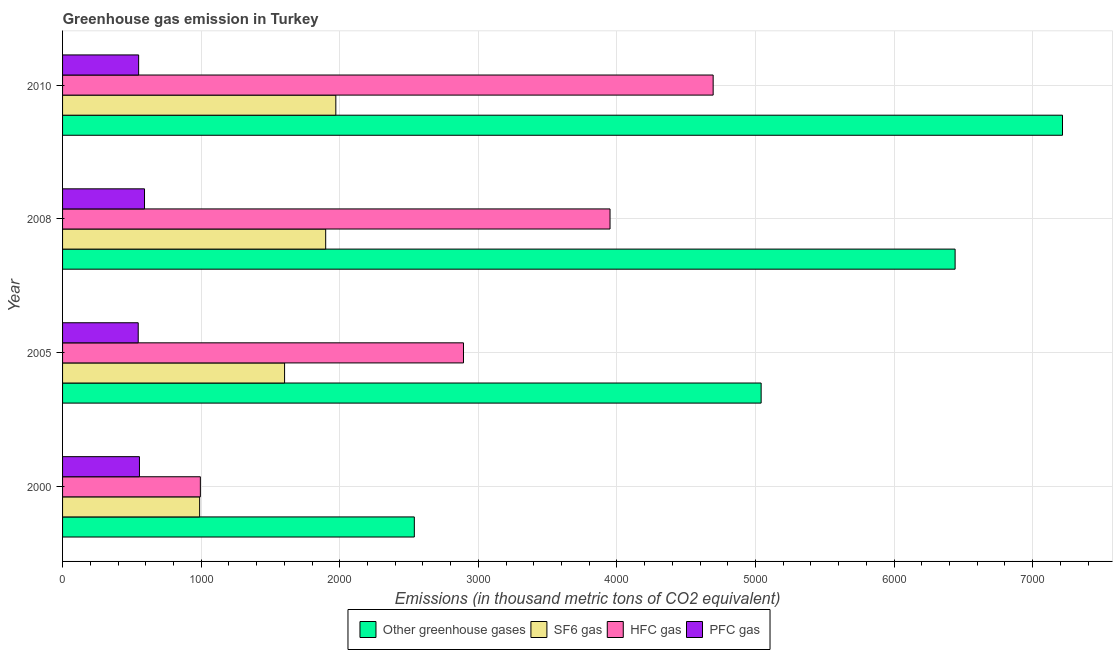How many different coloured bars are there?
Give a very brief answer. 4. How many groups of bars are there?
Give a very brief answer. 4. Are the number of bars per tick equal to the number of legend labels?
Provide a short and direct response. Yes. Are the number of bars on each tick of the Y-axis equal?
Make the answer very short. Yes. How many bars are there on the 3rd tick from the top?
Make the answer very short. 4. What is the label of the 1st group of bars from the top?
Provide a succinct answer. 2010. What is the emission of pfc gas in 2005?
Provide a short and direct response. 545.9. Across all years, what is the maximum emission of sf6 gas?
Offer a very short reply. 1972. Across all years, what is the minimum emission of hfc gas?
Provide a short and direct response. 994.4. What is the total emission of sf6 gas in the graph?
Your response must be concise. 6462.2. What is the difference between the emission of hfc gas in 2005 and that in 2010?
Give a very brief answer. -1801.8. What is the difference between the emission of pfc gas in 2000 and the emission of greenhouse gases in 2005?
Ensure brevity in your answer.  -4486.4. What is the average emission of sf6 gas per year?
Your answer should be very brief. 1615.55. In the year 2005, what is the difference between the emission of hfc gas and emission of greenhouse gases?
Offer a very short reply. -2148.1. In how many years, is the emission of sf6 gas greater than 1000 thousand metric tons?
Your answer should be compact. 3. What is the ratio of the emission of pfc gas in 2000 to that in 2005?
Provide a succinct answer. 1.02. Is the difference between the emission of pfc gas in 2005 and 2010 greater than the difference between the emission of sf6 gas in 2005 and 2010?
Make the answer very short. Yes. What is the difference between the highest and the second highest emission of pfc gas?
Your answer should be very brief. 36.5. What is the difference between the highest and the lowest emission of greenhouse gases?
Offer a terse response. 4677.5. Is it the case that in every year, the sum of the emission of greenhouse gases and emission of sf6 gas is greater than the sum of emission of hfc gas and emission of pfc gas?
Offer a very short reply. No. What does the 1st bar from the top in 2005 represents?
Your response must be concise. PFC gas. What does the 1st bar from the bottom in 2010 represents?
Ensure brevity in your answer.  Other greenhouse gases. How many bars are there?
Your response must be concise. 16. Are all the bars in the graph horizontal?
Ensure brevity in your answer.  Yes. How many years are there in the graph?
Your answer should be compact. 4. What is the difference between two consecutive major ticks on the X-axis?
Your response must be concise. 1000. Are the values on the major ticks of X-axis written in scientific E-notation?
Offer a very short reply. No. Does the graph contain any zero values?
Give a very brief answer. No. Where does the legend appear in the graph?
Provide a short and direct response. Bottom center. How are the legend labels stacked?
Your response must be concise. Horizontal. What is the title of the graph?
Your response must be concise. Greenhouse gas emission in Turkey. Does "Third 20% of population" appear as one of the legend labels in the graph?
Keep it short and to the point. No. What is the label or title of the X-axis?
Your answer should be very brief. Emissions (in thousand metric tons of CO2 equivalent). What is the Emissions (in thousand metric tons of CO2 equivalent) of Other greenhouse gases in 2000?
Ensure brevity in your answer.  2538.5. What is the Emissions (in thousand metric tons of CO2 equivalent) in SF6 gas in 2000?
Give a very brief answer. 989.2. What is the Emissions (in thousand metric tons of CO2 equivalent) of HFC gas in 2000?
Offer a very short reply. 994.4. What is the Emissions (in thousand metric tons of CO2 equivalent) in PFC gas in 2000?
Your response must be concise. 554.9. What is the Emissions (in thousand metric tons of CO2 equivalent) in Other greenhouse gases in 2005?
Make the answer very short. 5041.3. What is the Emissions (in thousand metric tons of CO2 equivalent) in SF6 gas in 2005?
Make the answer very short. 1602.2. What is the Emissions (in thousand metric tons of CO2 equivalent) in HFC gas in 2005?
Your answer should be compact. 2893.2. What is the Emissions (in thousand metric tons of CO2 equivalent) of PFC gas in 2005?
Ensure brevity in your answer.  545.9. What is the Emissions (in thousand metric tons of CO2 equivalent) in Other greenhouse gases in 2008?
Provide a short and direct response. 6441. What is the Emissions (in thousand metric tons of CO2 equivalent) in SF6 gas in 2008?
Keep it short and to the point. 1898.8. What is the Emissions (in thousand metric tons of CO2 equivalent) in HFC gas in 2008?
Your answer should be very brief. 3950.8. What is the Emissions (in thousand metric tons of CO2 equivalent) in PFC gas in 2008?
Your response must be concise. 591.4. What is the Emissions (in thousand metric tons of CO2 equivalent) of Other greenhouse gases in 2010?
Offer a terse response. 7216. What is the Emissions (in thousand metric tons of CO2 equivalent) in SF6 gas in 2010?
Your answer should be compact. 1972. What is the Emissions (in thousand metric tons of CO2 equivalent) in HFC gas in 2010?
Keep it short and to the point. 4695. What is the Emissions (in thousand metric tons of CO2 equivalent) in PFC gas in 2010?
Provide a succinct answer. 549. Across all years, what is the maximum Emissions (in thousand metric tons of CO2 equivalent) of Other greenhouse gases?
Give a very brief answer. 7216. Across all years, what is the maximum Emissions (in thousand metric tons of CO2 equivalent) of SF6 gas?
Make the answer very short. 1972. Across all years, what is the maximum Emissions (in thousand metric tons of CO2 equivalent) of HFC gas?
Give a very brief answer. 4695. Across all years, what is the maximum Emissions (in thousand metric tons of CO2 equivalent) of PFC gas?
Your response must be concise. 591.4. Across all years, what is the minimum Emissions (in thousand metric tons of CO2 equivalent) of Other greenhouse gases?
Keep it short and to the point. 2538.5. Across all years, what is the minimum Emissions (in thousand metric tons of CO2 equivalent) of SF6 gas?
Your response must be concise. 989.2. Across all years, what is the minimum Emissions (in thousand metric tons of CO2 equivalent) in HFC gas?
Give a very brief answer. 994.4. Across all years, what is the minimum Emissions (in thousand metric tons of CO2 equivalent) of PFC gas?
Give a very brief answer. 545.9. What is the total Emissions (in thousand metric tons of CO2 equivalent) of Other greenhouse gases in the graph?
Make the answer very short. 2.12e+04. What is the total Emissions (in thousand metric tons of CO2 equivalent) of SF6 gas in the graph?
Provide a succinct answer. 6462.2. What is the total Emissions (in thousand metric tons of CO2 equivalent) of HFC gas in the graph?
Your answer should be very brief. 1.25e+04. What is the total Emissions (in thousand metric tons of CO2 equivalent) of PFC gas in the graph?
Offer a very short reply. 2241.2. What is the difference between the Emissions (in thousand metric tons of CO2 equivalent) of Other greenhouse gases in 2000 and that in 2005?
Ensure brevity in your answer.  -2502.8. What is the difference between the Emissions (in thousand metric tons of CO2 equivalent) in SF6 gas in 2000 and that in 2005?
Make the answer very short. -613. What is the difference between the Emissions (in thousand metric tons of CO2 equivalent) in HFC gas in 2000 and that in 2005?
Keep it short and to the point. -1898.8. What is the difference between the Emissions (in thousand metric tons of CO2 equivalent) in Other greenhouse gases in 2000 and that in 2008?
Offer a very short reply. -3902.5. What is the difference between the Emissions (in thousand metric tons of CO2 equivalent) in SF6 gas in 2000 and that in 2008?
Keep it short and to the point. -909.6. What is the difference between the Emissions (in thousand metric tons of CO2 equivalent) in HFC gas in 2000 and that in 2008?
Ensure brevity in your answer.  -2956.4. What is the difference between the Emissions (in thousand metric tons of CO2 equivalent) in PFC gas in 2000 and that in 2008?
Your answer should be very brief. -36.5. What is the difference between the Emissions (in thousand metric tons of CO2 equivalent) in Other greenhouse gases in 2000 and that in 2010?
Provide a short and direct response. -4677.5. What is the difference between the Emissions (in thousand metric tons of CO2 equivalent) in SF6 gas in 2000 and that in 2010?
Provide a succinct answer. -982.8. What is the difference between the Emissions (in thousand metric tons of CO2 equivalent) in HFC gas in 2000 and that in 2010?
Offer a terse response. -3700.6. What is the difference between the Emissions (in thousand metric tons of CO2 equivalent) in Other greenhouse gases in 2005 and that in 2008?
Give a very brief answer. -1399.7. What is the difference between the Emissions (in thousand metric tons of CO2 equivalent) of SF6 gas in 2005 and that in 2008?
Provide a short and direct response. -296.6. What is the difference between the Emissions (in thousand metric tons of CO2 equivalent) in HFC gas in 2005 and that in 2008?
Give a very brief answer. -1057.6. What is the difference between the Emissions (in thousand metric tons of CO2 equivalent) of PFC gas in 2005 and that in 2008?
Make the answer very short. -45.5. What is the difference between the Emissions (in thousand metric tons of CO2 equivalent) of Other greenhouse gases in 2005 and that in 2010?
Ensure brevity in your answer.  -2174.7. What is the difference between the Emissions (in thousand metric tons of CO2 equivalent) of SF6 gas in 2005 and that in 2010?
Your answer should be compact. -369.8. What is the difference between the Emissions (in thousand metric tons of CO2 equivalent) in HFC gas in 2005 and that in 2010?
Give a very brief answer. -1801.8. What is the difference between the Emissions (in thousand metric tons of CO2 equivalent) in PFC gas in 2005 and that in 2010?
Your answer should be compact. -3.1. What is the difference between the Emissions (in thousand metric tons of CO2 equivalent) in Other greenhouse gases in 2008 and that in 2010?
Offer a terse response. -775. What is the difference between the Emissions (in thousand metric tons of CO2 equivalent) in SF6 gas in 2008 and that in 2010?
Your answer should be compact. -73.2. What is the difference between the Emissions (in thousand metric tons of CO2 equivalent) of HFC gas in 2008 and that in 2010?
Your answer should be compact. -744.2. What is the difference between the Emissions (in thousand metric tons of CO2 equivalent) of PFC gas in 2008 and that in 2010?
Offer a very short reply. 42.4. What is the difference between the Emissions (in thousand metric tons of CO2 equivalent) of Other greenhouse gases in 2000 and the Emissions (in thousand metric tons of CO2 equivalent) of SF6 gas in 2005?
Your answer should be very brief. 936.3. What is the difference between the Emissions (in thousand metric tons of CO2 equivalent) of Other greenhouse gases in 2000 and the Emissions (in thousand metric tons of CO2 equivalent) of HFC gas in 2005?
Your answer should be very brief. -354.7. What is the difference between the Emissions (in thousand metric tons of CO2 equivalent) of Other greenhouse gases in 2000 and the Emissions (in thousand metric tons of CO2 equivalent) of PFC gas in 2005?
Keep it short and to the point. 1992.6. What is the difference between the Emissions (in thousand metric tons of CO2 equivalent) of SF6 gas in 2000 and the Emissions (in thousand metric tons of CO2 equivalent) of HFC gas in 2005?
Offer a very short reply. -1904. What is the difference between the Emissions (in thousand metric tons of CO2 equivalent) of SF6 gas in 2000 and the Emissions (in thousand metric tons of CO2 equivalent) of PFC gas in 2005?
Keep it short and to the point. 443.3. What is the difference between the Emissions (in thousand metric tons of CO2 equivalent) in HFC gas in 2000 and the Emissions (in thousand metric tons of CO2 equivalent) in PFC gas in 2005?
Ensure brevity in your answer.  448.5. What is the difference between the Emissions (in thousand metric tons of CO2 equivalent) in Other greenhouse gases in 2000 and the Emissions (in thousand metric tons of CO2 equivalent) in SF6 gas in 2008?
Offer a terse response. 639.7. What is the difference between the Emissions (in thousand metric tons of CO2 equivalent) of Other greenhouse gases in 2000 and the Emissions (in thousand metric tons of CO2 equivalent) of HFC gas in 2008?
Ensure brevity in your answer.  -1412.3. What is the difference between the Emissions (in thousand metric tons of CO2 equivalent) of Other greenhouse gases in 2000 and the Emissions (in thousand metric tons of CO2 equivalent) of PFC gas in 2008?
Offer a very short reply. 1947.1. What is the difference between the Emissions (in thousand metric tons of CO2 equivalent) of SF6 gas in 2000 and the Emissions (in thousand metric tons of CO2 equivalent) of HFC gas in 2008?
Provide a succinct answer. -2961.6. What is the difference between the Emissions (in thousand metric tons of CO2 equivalent) of SF6 gas in 2000 and the Emissions (in thousand metric tons of CO2 equivalent) of PFC gas in 2008?
Your response must be concise. 397.8. What is the difference between the Emissions (in thousand metric tons of CO2 equivalent) in HFC gas in 2000 and the Emissions (in thousand metric tons of CO2 equivalent) in PFC gas in 2008?
Offer a terse response. 403. What is the difference between the Emissions (in thousand metric tons of CO2 equivalent) in Other greenhouse gases in 2000 and the Emissions (in thousand metric tons of CO2 equivalent) in SF6 gas in 2010?
Provide a short and direct response. 566.5. What is the difference between the Emissions (in thousand metric tons of CO2 equivalent) of Other greenhouse gases in 2000 and the Emissions (in thousand metric tons of CO2 equivalent) of HFC gas in 2010?
Provide a short and direct response. -2156.5. What is the difference between the Emissions (in thousand metric tons of CO2 equivalent) of Other greenhouse gases in 2000 and the Emissions (in thousand metric tons of CO2 equivalent) of PFC gas in 2010?
Your response must be concise. 1989.5. What is the difference between the Emissions (in thousand metric tons of CO2 equivalent) in SF6 gas in 2000 and the Emissions (in thousand metric tons of CO2 equivalent) in HFC gas in 2010?
Offer a terse response. -3705.8. What is the difference between the Emissions (in thousand metric tons of CO2 equivalent) of SF6 gas in 2000 and the Emissions (in thousand metric tons of CO2 equivalent) of PFC gas in 2010?
Keep it short and to the point. 440.2. What is the difference between the Emissions (in thousand metric tons of CO2 equivalent) in HFC gas in 2000 and the Emissions (in thousand metric tons of CO2 equivalent) in PFC gas in 2010?
Offer a very short reply. 445.4. What is the difference between the Emissions (in thousand metric tons of CO2 equivalent) of Other greenhouse gases in 2005 and the Emissions (in thousand metric tons of CO2 equivalent) of SF6 gas in 2008?
Offer a terse response. 3142.5. What is the difference between the Emissions (in thousand metric tons of CO2 equivalent) in Other greenhouse gases in 2005 and the Emissions (in thousand metric tons of CO2 equivalent) in HFC gas in 2008?
Give a very brief answer. 1090.5. What is the difference between the Emissions (in thousand metric tons of CO2 equivalent) of Other greenhouse gases in 2005 and the Emissions (in thousand metric tons of CO2 equivalent) of PFC gas in 2008?
Your answer should be very brief. 4449.9. What is the difference between the Emissions (in thousand metric tons of CO2 equivalent) in SF6 gas in 2005 and the Emissions (in thousand metric tons of CO2 equivalent) in HFC gas in 2008?
Provide a succinct answer. -2348.6. What is the difference between the Emissions (in thousand metric tons of CO2 equivalent) of SF6 gas in 2005 and the Emissions (in thousand metric tons of CO2 equivalent) of PFC gas in 2008?
Provide a succinct answer. 1010.8. What is the difference between the Emissions (in thousand metric tons of CO2 equivalent) of HFC gas in 2005 and the Emissions (in thousand metric tons of CO2 equivalent) of PFC gas in 2008?
Give a very brief answer. 2301.8. What is the difference between the Emissions (in thousand metric tons of CO2 equivalent) of Other greenhouse gases in 2005 and the Emissions (in thousand metric tons of CO2 equivalent) of SF6 gas in 2010?
Keep it short and to the point. 3069.3. What is the difference between the Emissions (in thousand metric tons of CO2 equivalent) of Other greenhouse gases in 2005 and the Emissions (in thousand metric tons of CO2 equivalent) of HFC gas in 2010?
Ensure brevity in your answer.  346.3. What is the difference between the Emissions (in thousand metric tons of CO2 equivalent) of Other greenhouse gases in 2005 and the Emissions (in thousand metric tons of CO2 equivalent) of PFC gas in 2010?
Your answer should be compact. 4492.3. What is the difference between the Emissions (in thousand metric tons of CO2 equivalent) of SF6 gas in 2005 and the Emissions (in thousand metric tons of CO2 equivalent) of HFC gas in 2010?
Offer a very short reply. -3092.8. What is the difference between the Emissions (in thousand metric tons of CO2 equivalent) of SF6 gas in 2005 and the Emissions (in thousand metric tons of CO2 equivalent) of PFC gas in 2010?
Provide a succinct answer. 1053.2. What is the difference between the Emissions (in thousand metric tons of CO2 equivalent) of HFC gas in 2005 and the Emissions (in thousand metric tons of CO2 equivalent) of PFC gas in 2010?
Offer a terse response. 2344.2. What is the difference between the Emissions (in thousand metric tons of CO2 equivalent) of Other greenhouse gases in 2008 and the Emissions (in thousand metric tons of CO2 equivalent) of SF6 gas in 2010?
Ensure brevity in your answer.  4469. What is the difference between the Emissions (in thousand metric tons of CO2 equivalent) of Other greenhouse gases in 2008 and the Emissions (in thousand metric tons of CO2 equivalent) of HFC gas in 2010?
Offer a very short reply. 1746. What is the difference between the Emissions (in thousand metric tons of CO2 equivalent) in Other greenhouse gases in 2008 and the Emissions (in thousand metric tons of CO2 equivalent) in PFC gas in 2010?
Your response must be concise. 5892. What is the difference between the Emissions (in thousand metric tons of CO2 equivalent) of SF6 gas in 2008 and the Emissions (in thousand metric tons of CO2 equivalent) of HFC gas in 2010?
Offer a terse response. -2796.2. What is the difference between the Emissions (in thousand metric tons of CO2 equivalent) of SF6 gas in 2008 and the Emissions (in thousand metric tons of CO2 equivalent) of PFC gas in 2010?
Keep it short and to the point. 1349.8. What is the difference between the Emissions (in thousand metric tons of CO2 equivalent) of HFC gas in 2008 and the Emissions (in thousand metric tons of CO2 equivalent) of PFC gas in 2010?
Provide a succinct answer. 3401.8. What is the average Emissions (in thousand metric tons of CO2 equivalent) of Other greenhouse gases per year?
Provide a succinct answer. 5309.2. What is the average Emissions (in thousand metric tons of CO2 equivalent) in SF6 gas per year?
Your answer should be compact. 1615.55. What is the average Emissions (in thousand metric tons of CO2 equivalent) in HFC gas per year?
Offer a very short reply. 3133.35. What is the average Emissions (in thousand metric tons of CO2 equivalent) in PFC gas per year?
Your response must be concise. 560.3. In the year 2000, what is the difference between the Emissions (in thousand metric tons of CO2 equivalent) of Other greenhouse gases and Emissions (in thousand metric tons of CO2 equivalent) of SF6 gas?
Give a very brief answer. 1549.3. In the year 2000, what is the difference between the Emissions (in thousand metric tons of CO2 equivalent) in Other greenhouse gases and Emissions (in thousand metric tons of CO2 equivalent) in HFC gas?
Offer a very short reply. 1544.1. In the year 2000, what is the difference between the Emissions (in thousand metric tons of CO2 equivalent) of Other greenhouse gases and Emissions (in thousand metric tons of CO2 equivalent) of PFC gas?
Keep it short and to the point. 1983.6. In the year 2000, what is the difference between the Emissions (in thousand metric tons of CO2 equivalent) of SF6 gas and Emissions (in thousand metric tons of CO2 equivalent) of HFC gas?
Your answer should be very brief. -5.2. In the year 2000, what is the difference between the Emissions (in thousand metric tons of CO2 equivalent) in SF6 gas and Emissions (in thousand metric tons of CO2 equivalent) in PFC gas?
Give a very brief answer. 434.3. In the year 2000, what is the difference between the Emissions (in thousand metric tons of CO2 equivalent) of HFC gas and Emissions (in thousand metric tons of CO2 equivalent) of PFC gas?
Your answer should be very brief. 439.5. In the year 2005, what is the difference between the Emissions (in thousand metric tons of CO2 equivalent) of Other greenhouse gases and Emissions (in thousand metric tons of CO2 equivalent) of SF6 gas?
Give a very brief answer. 3439.1. In the year 2005, what is the difference between the Emissions (in thousand metric tons of CO2 equivalent) of Other greenhouse gases and Emissions (in thousand metric tons of CO2 equivalent) of HFC gas?
Make the answer very short. 2148.1. In the year 2005, what is the difference between the Emissions (in thousand metric tons of CO2 equivalent) of Other greenhouse gases and Emissions (in thousand metric tons of CO2 equivalent) of PFC gas?
Your response must be concise. 4495.4. In the year 2005, what is the difference between the Emissions (in thousand metric tons of CO2 equivalent) of SF6 gas and Emissions (in thousand metric tons of CO2 equivalent) of HFC gas?
Your response must be concise. -1291. In the year 2005, what is the difference between the Emissions (in thousand metric tons of CO2 equivalent) in SF6 gas and Emissions (in thousand metric tons of CO2 equivalent) in PFC gas?
Give a very brief answer. 1056.3. In the year 2005, what is the difference between the Emissions (in thousand metric tons of CO2 equivalent) in HFC gas and Emissions (in thousand metric tons of CO2 equivalent) in PFC gas?
Provide a short and direct response. 2347.3. In the year 2008, what is the difference between the Emissions (in thousand metric tons of CO2 equivalent) in Other greenhouse gases and Emissions (in thousand metric tons of CO2 equivalent) in SF6 gas?
Your response must be concise. 4542.2. In the year 2008, what is the difference between the Emissions (in thousand metric tons of CO2 equivalent) of Other greenhouse gases and Emissions (in thousand metric tons of CO2 equivalent) of HFC gas?
Keep it short and to the point. 2490.2. In the year 2008, what is the difference between the Emissions (in thousand metric tons of CO2 equivalent) of Other greenhouse gases and Emissions (in thousand metric tons of CO2 equivalent) of PFC gas?
Keep it short and to the point. 5849.6. In the year 2008, what is the difference between the Emissions (in thousand metric tons of CO2 equivalent) in SF6 gas and Emissions (in thousand metric tons of CO2 equivalent) in HFC gas?
Your answer should be compact. -2052. In the year 2008, what is the difference between the Emissions (in thousand metric tons of CO2 equivalent) of SF6 gas and Emissions (in thousand metric tons of CO2 equivalent) of PFC gas?
Ensure brevity in your answer.  1307.4. In the year 2008, what is the difference between the Emissions (in thousand metric tons of CO2 equivalent) in HFC gas and Emissions (in thousand metric tons of CO2 equivalent) in PFC gas?
Your response must be concise. 3359.4. In the year 2010, what is the difference between the Emissions (in thousand metric tons of CO2 equivalent) in Other greenhouse gases and Emissions (in thousand metric tons of CO2 equivalent) in SF6 gas?
Give a very brief answer. 5244. In the year 2010, what is the difference between the Emissions (in thousand metric tons of CO2 equivalent) in Other greenhouse gases and Emissions (in thousand metric tons of CO2 equivalent) in HFC gas?
Keep it short and to the point. 2521. In the year 2010, what is the difference between the Emissions (in thousand metric tons of CO2 equivalent) of Other greenhouse gases and Emissions (in thousand metric tons of CO2 equivalent) of PFC gas?
Provide a short and direct response. 6667. In the year 2010, what is the difference between the Emissions (in thousand metric tons of CO2 equivalent) in SF6 gas and Emissions (in thousand metric tons of CO2 equivalent) in HFC gas?
Offer a terse response. -2723. In the year 2010, what is the difference between the Emissions (in thousand metric tons of CO2 equivalent) in SF6 gas and Emissions (in thousand metric tons of CO2 equivalent) in PFC gas?
Provide a short and direct response. 1423. In the year 2010, what is the difference between the Emissions (in thousand metric tons of CO2 equivalent) of HFC gas and Emissions (in thousand metric tons of CO2 equivalent) of PFC gas?
Your answer should be very brief. 4146. What is the ratio of the Emissions (in thousand metric tons of CO2 equivalent) of Other greenhouse gases in 2000 to that in 2005?
Give a very brief answer. 0.5. What is the ratio of the Emissions (in thousand metric tons of CO2 equivalent) of SF6 gas in 2000 to that in 2005?
Offer a terse response. 0.62. What is the ratio of the Emissions (in thousand metric tons of CO2 equivalent) of HFC gas in 2000 to that in 2005?
Keep it short and to the point. 0.34. What is the ratio of the Emissions (in thousand metric tons of CO2 equivalent) of PFC gas in 2000 to that in 2005?
Your answer should be very brief. 1.02. What is the ratio of the Emissions (in thousand metric tons of CO2 equivalent) of Other greenhouse gases in 2000 to that in 2008?
Your answer should be very brief. 0.39. What is the ratio of the Emissions (in thousand metric tons of CO2 equivalent) of SF6 gas in 2000 to that in 2008?
Your response must be concise. 0.52. What is the ratio of the Emissions (in thousand metric tons of CO2 equivalent) of HFC gas in 2000 to that in 2008?
Your answer should be compact. 0.25. What is the ratio of the Emissions (in thousand metric tons of CO2 equivalent) of PFC gas in 2000 to that in 2008?
Your answer should be very brief. 0.94. What is the ratio of the Emissions (in thousand metric tons of CO2 equivalent) of Other greenhouse gases in 2000 to that in 2010?
Offer a very short reply. 0.35. What is the ratio of the Emissions (in thousand metric tons of CO2 equivalent) in SF6 gas in 2000 to that in 2010?
Your answer should be compact. 0.5. What is the ratio of the Emissions (in thousand metric tons of CO2 equivalent) in HFC gas in 2000 to that in 2010?
Provide a short and direct response. 0.21. What is the ratio of the Emissions (in thousand metric tons of CO2 equivalent) of PFC gas in 2000 to that in 2010?
Offer a terse response. 1.01. What is the ratio of the Emissions (in thousand metric tons of CO2 equivalent) in Other greenhouse gases in 2005 to that in 2008?
Offer a terse response. 0.78. What is the ratio of the Emissions (in thousand metric tons of CO2 equivalent) of SF6 gas in 2005 to that in 2008?
Your answer should be compact. 0.84. What is the ratio of the Emissions (in thousand metric tons of CO2 equivalent) of HFC gas in 2005 to that in 2008?
Make the answer very short. 0.73. What is the ratio of the Emissions (in thousand metric tons of CO2 equivalent) in Other greenhouse gases in 2005 to that in 2010?
Give a very brief answer. 0.7. What is the ratio of the Emissions (in thousand metric tons of CO2 equivalent) in SF6 gas in 2005 to that in 2010?
Provide a succinct answer. 0.81. What is the ratio of the Emissions (in thousand metric tons of CO2 equivalent) of HFC gas in 2005 to that in 2010?
Your response must be concise. 0.62. What is the ratio of the Emissions (in thousand metric tons of CO2 equivalent) in Other greenhouse gases in 2008 to that in 2010?
Offer a very short reply. 0.89. What is the ratio of the Emissions (in thousand metric tons of CO2 equivalent) of SF6 gas in 2008 to that in 2010?
Your answer should be very brief. 0.96. What is the ratio of the Emissions (in thousand metric tons of CO2 equivalent) in HFC gas in 2008 to that in 2010?
Your answer should be very brief. 0.84. What is the ratio of the Emissions (in thousand metric tons of CO2 equivalent) of PFC gas in 2008 to that in 2010?
Your response must be concise. 1.08. What is the difference between the highest and the second highest Emissions (in thousand metric tons of CO2 equivalent) in Other greenhouse gases?
Your answer should be very brief. 775. What is the difference between the highest and the second highest Emissions (in thousand metric tons of CO2 equivalent) of SF6 gas?
Provide a succinct answer. 73.2. What is the difference between the highest and the second highest Emissions (in thousand metric tons of CO2 equivalent) of HFC gas?
Offer a terse response. 744.2. What is the difference between the highest and the second highest Emissions (in thousand metric tons of CO2 equivalent) in PFC gas?
Provide a succinct answer. 36.5. What is the difference between the highest and the lowest Emissions (in thousand metric tons of CO2 equivalent) in Other greenhouse gases?
Provide a short and direct response. 4677.5. What is the difference between the highest and the lowest Emissions (in thousand metric tons of CO2 equivalent) in SF6 gas?
Provide a short and direct response. 982.8. What is the difference between the highest and the lowest Emissions (in thousand metric tons of CO2 equivalent) of HFC gas?
Offer a very short reply. 3700.6. What is the difference between the highest and the lowest Emissions (in thousand metric tons of CO2 equivalent) in PFC gas?
Provide a succinct answer. 45.5. 